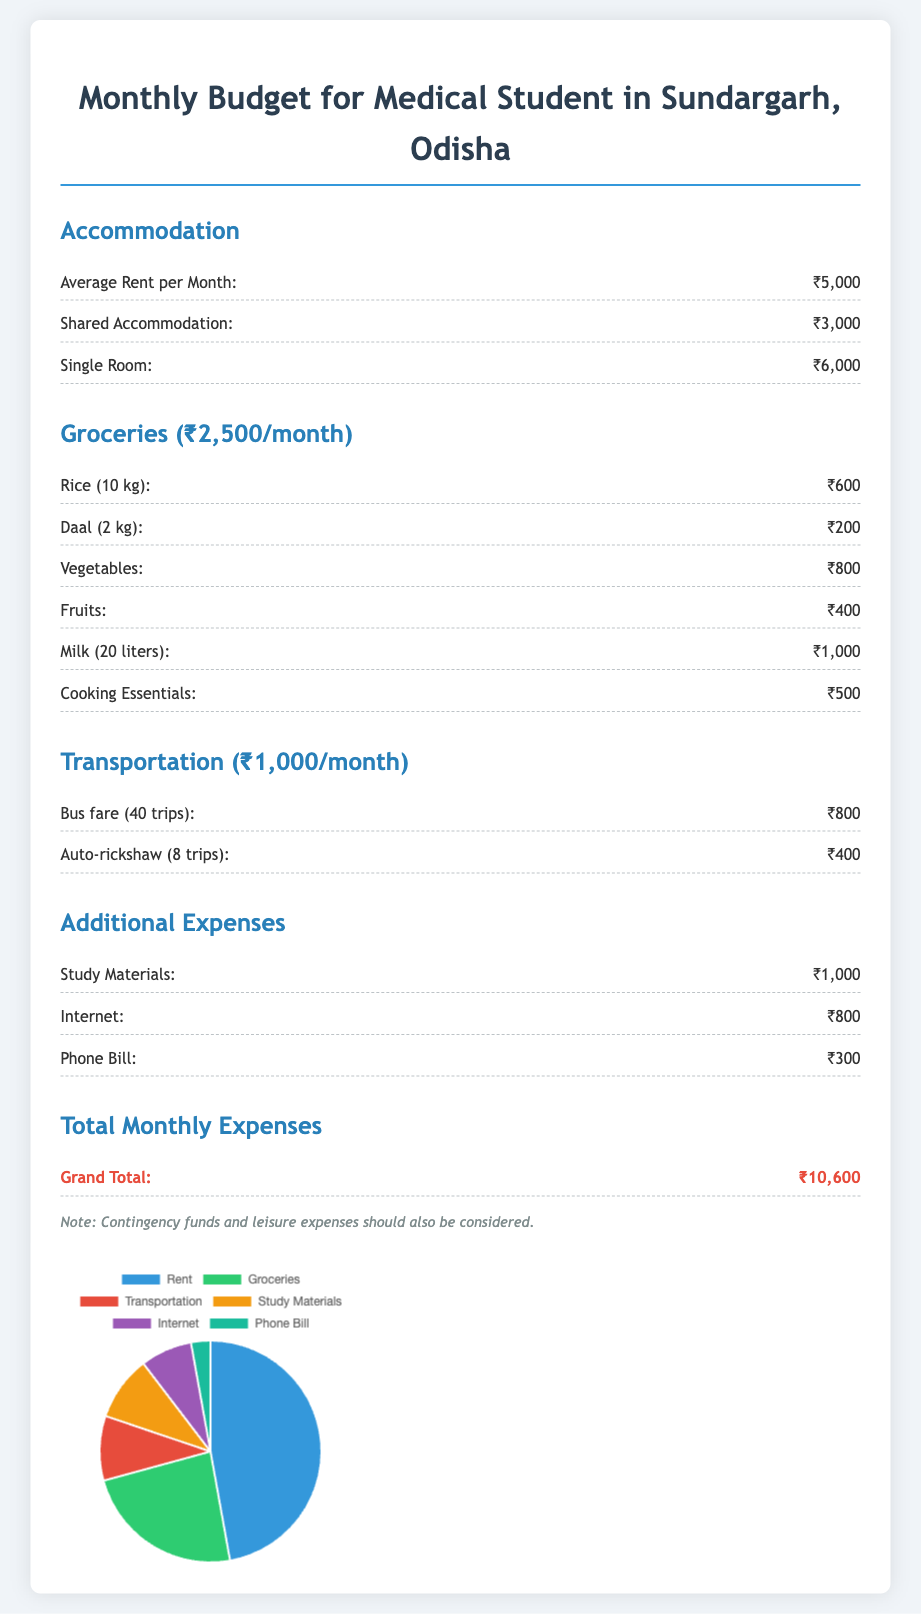What is the average rent per month? The average rent per month listed in the document is ₹5,000.
Answer: ₹5,000 What is the total cost for groceries? The document states that the total cost for groceries is ₹2,500 per month.
Answer: ₹2,500 How much is spent on transportation each month? The monthly transportation cost mentioned in the document is ₹1,000.
Answer: ₹1,000 What is the total monthly budget for a medical student? The grand total of all expenses is provided at the end of the document, which is ₹10,600.
Answer: ₹10,600 How much is allocated for study materials? The budget for study materials is outlined in the additional expenses section as ₹1,000.
Answer: ₹1,000 What are the total costs for additional expenses? The sum of additional expenses including study materials, internet, and phone bill is ₹2,100 (₹1,000 + ₹800 + ₹300).
Answer: ₹2,100 What is the cost of milk per month? The cost of milk for 20 liters is detailed in the groceries section as ₹1,000.
Answer: ₹1,000 How many trips can be made on public transport with the transportation budget? The document mentions that the bus fare for 40 trips costs ₹800.
Answer: 40 trips Which section has the highest expense? The accommodation section has the highest expense with an average rent of ₹5,000.
Answer: Accommodation 